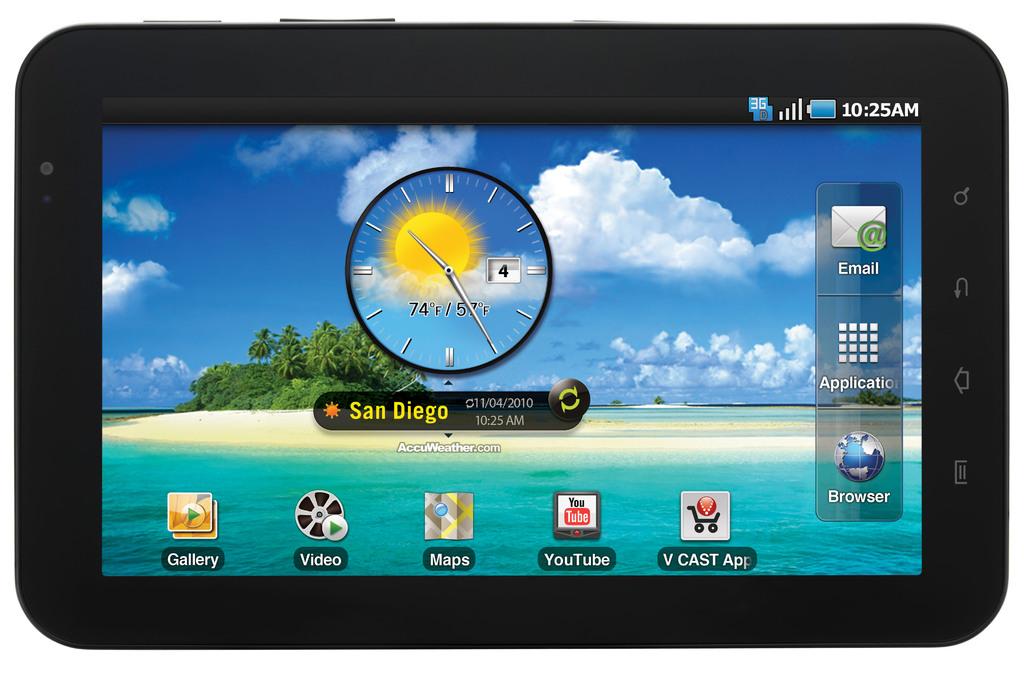What city is displayed on the center of the screen?
Give a very brief answer. San diego. 